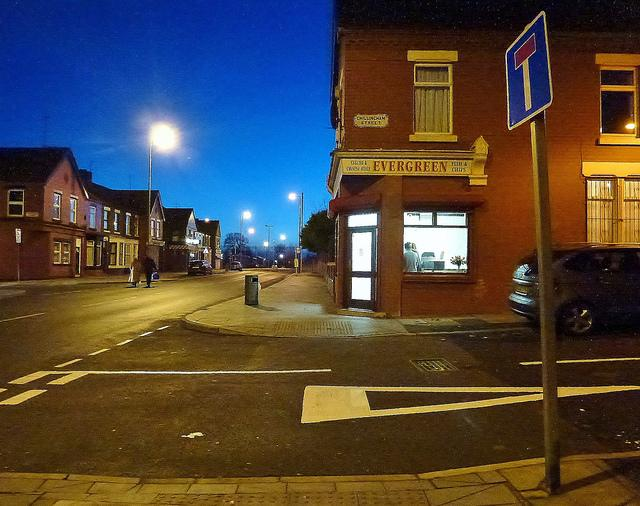What does the blue road sign warn of? dead end 